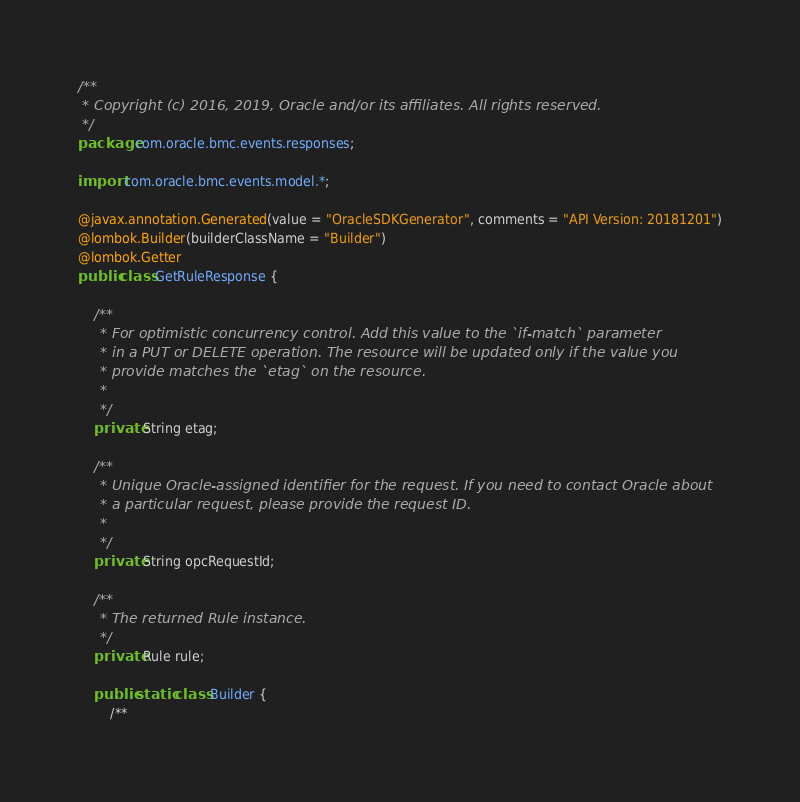Convert code to text. <code><loc_0><loc_0><loc_500><loc_500><_Java_>/**
 * Copyright (c) 2016, 2019, Oracle and/or its affiliates. All rights reserved.
 */
package com.oracle.bmc.events.responses;

import com.oracle.bmc.events.model.*;

@javax.annotation.Generated(value = "OracleSDKGenerator", comments = "API Version: 20181201")
@lombok.Builder(builderClassName = "Builder")
@lombok.Getter
public class GetRuleResponse {

    /**
     * For optimistic concurrency control. Add this value to the `if-match` parameter
     * in a PUT or DELETE operation. The resource will be updated only if the value you
     * provide matches the `etag` on the resource.
     *
     */
    private String etag;

    /**
     * Unique Oracle-assigned identifier for the request. If you need to contact Oracle about
     * a particular request, please provide the request ID.
     *
     */
    private String opcRequestId;

    /**
     * The returned Rule instance.
     */
    private Rule rule;

    public static class Builder {
        /**</code> 